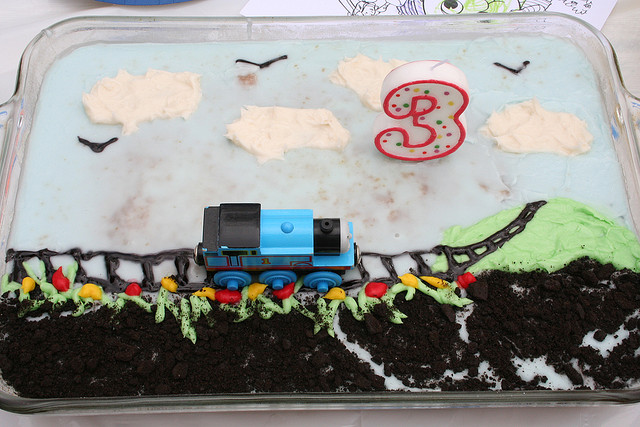<image>What vegetable makes up the grass? There are no vegetables that make up the grass. What vegetable makes up the grass? I don't know what vegetable makes up the grass. It can be none or any vegetable mentioned. 